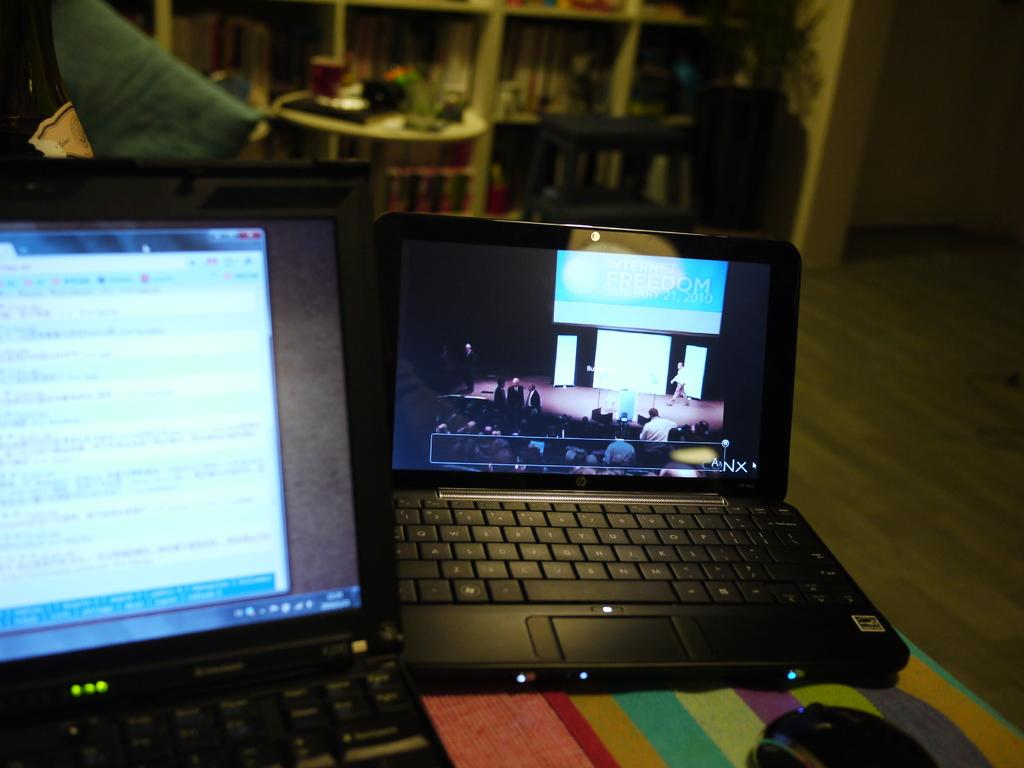<image>
Write a terse but informative summary of the picture. A laptop features a forum for Internet Freedom on its screen. 